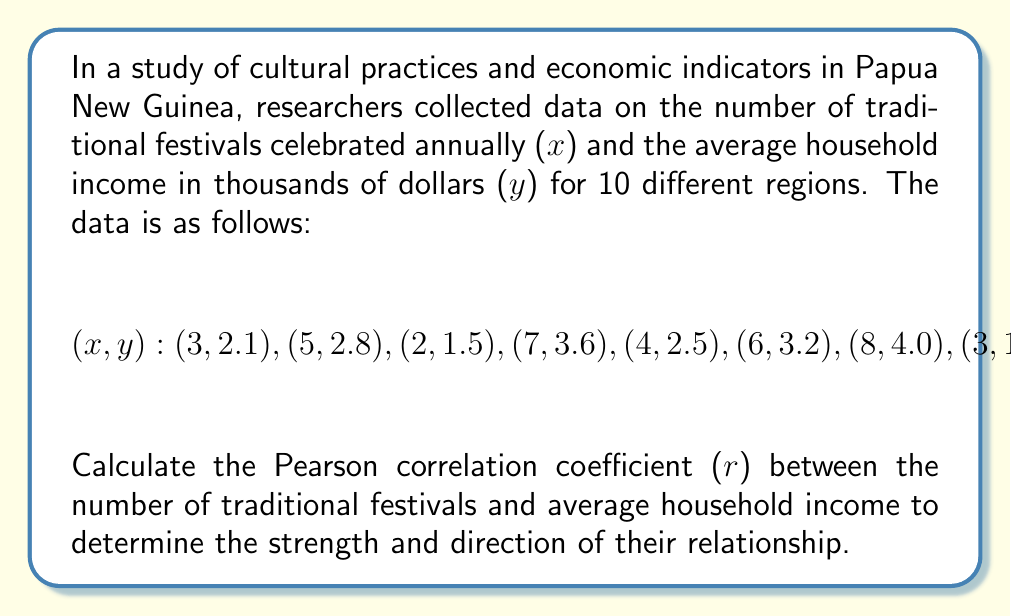Provide a solution to this math problem. To calculate the Pearson correlation coefficient (r), we'll use the formula:

$$r = \frac{n\sum xy - (\sum x)(\sum y)}{\sqrt{[n\sum x^2 - (\sum x)^2][n\sum y^2 - (\sum y)^2]}}$$

Step 1: Calculate the sums and squared sums:
$\sum x = 47$
$\sum y = 26.6$
$\sum xy = 137.9$
$\sum x^2 = 259$
$\sum y^2 = 75.74$

Step 2: Calculate $n\sum xy$ and $(\sum x)(\sum y)$:
$n\sum xy = 10 \times 137.9 = 1379$
$(\sum x)(\sum y) = 47 \times 26.6 = 1250.2$

Step 3: Calculate $n\sum x^2$ and $(\sum x)^2$:
$n\sum x^2 = 10 \times 259 = 2590$
$(\sum x)^2 = 47^2 = 2209$

Step 4: Calculate $n\sum y^2$ and $(\sum y)^2$:
$n\sum y^2 = 10 \times 75.74 = 757.4$
$(\sum y)^2 = 26.6^2 = 707.56$

Step 5: Apply the formula:

$$r = \frac{1379 - 1250.2}{\sqrt{(2590 - 2209)(757.4 - 707.56)}}$$

$$r = \frac{128.8}{\sqrt{381 \times 49.84}}$$

$$r = \frac{128.8}{\sqrt{18988.04}}$$

$$r = \frac{128.8}{137.8}$$

$$r \approx 0.9346$$
Answer: $r \approx 0.9346$ 